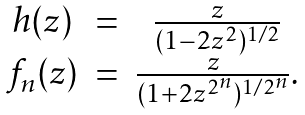Convert formula to latex. <formula><loc_0><loc_0><loc_500><loc_500>\begin{array} { c c c } h ( z ) & = & \frac { z } { ( 1 - 2 z ^ { 2 } ) ^ { 1 / 2 } } \\ f _ { n } ( z ) & = & \frac { z } { ( 1 + 2 z ^ { 2 ^ { n } } ) ^ { 1 / 2 ^ { n } } } . \end{array}</formula> 